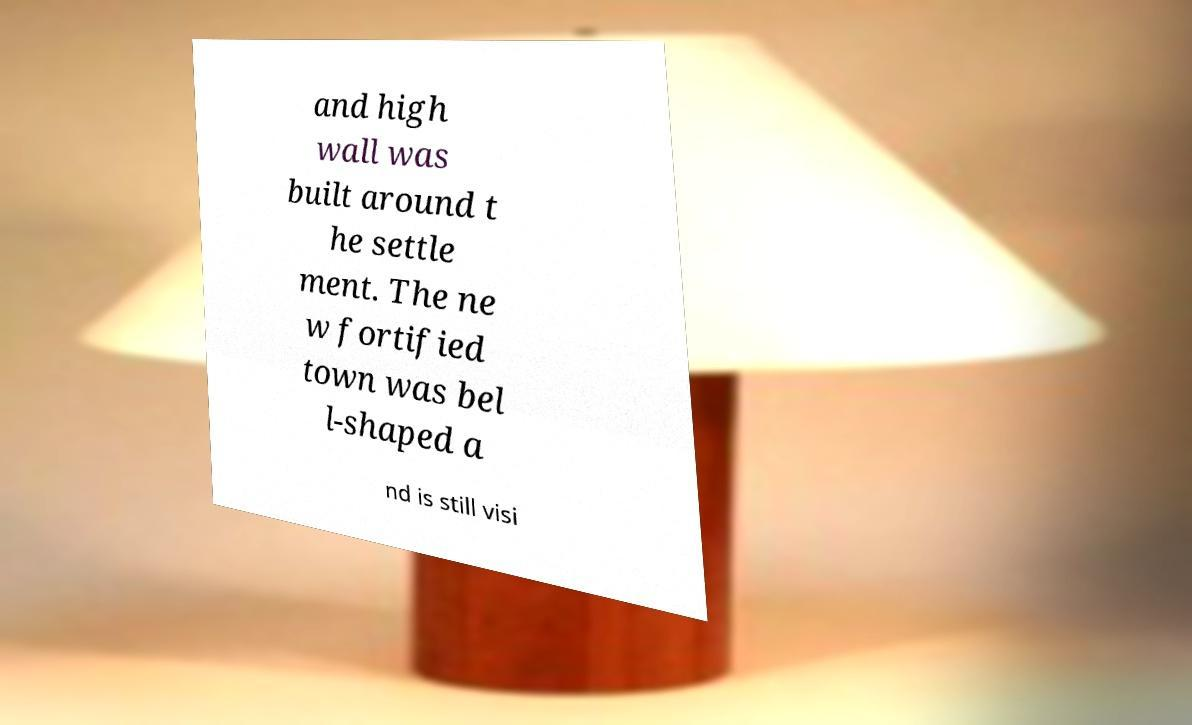Please identify and transcribe the text found in this image. and high wall was built around t he settle ment. The ne w fortified town was bel l-shaped a nd is still visi 